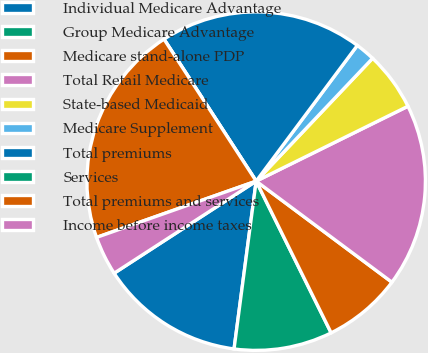Convert chart to OTSL. <chart><loc_0><loc_0><loc_500><loc_500><pie_chart><fcel>Individual Medicare Advantage<fcel>Group Medicare Advantage<fcel>Medicare stand-alone PDP<fcel>Total Retail Medicare<fcel>State-based Medicaid<fcel>Medicare Supplement<fcel>Total premiums<fcel>Services<fcel>Total premiums and services<fcel>Income before income taxes<nl><fcel>13.76%<fcel>9.39%<fcel>7.51%<fcel>17.48%<fcel>5.63%<fcel>1.88%<fcel>19.36%<fcel>0.0%<fcel>21.23%<fcel>3.76%<nl></chart> 